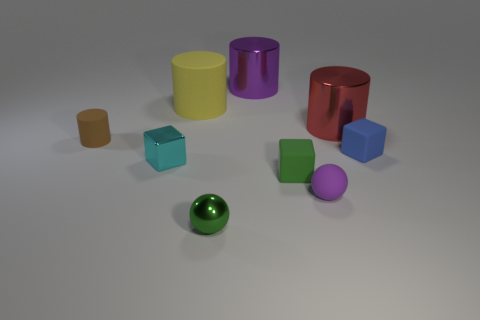There is a tiny matte object that is the same color as the tiny shiny ball; what shape is it? The tiny matte object that shares the same color as the tiny shiny ball is a cube. This geometrically precise shape has six faces, each with equal square dimensions, and contrasts with the smooth, curved surface of the spherical ball. 